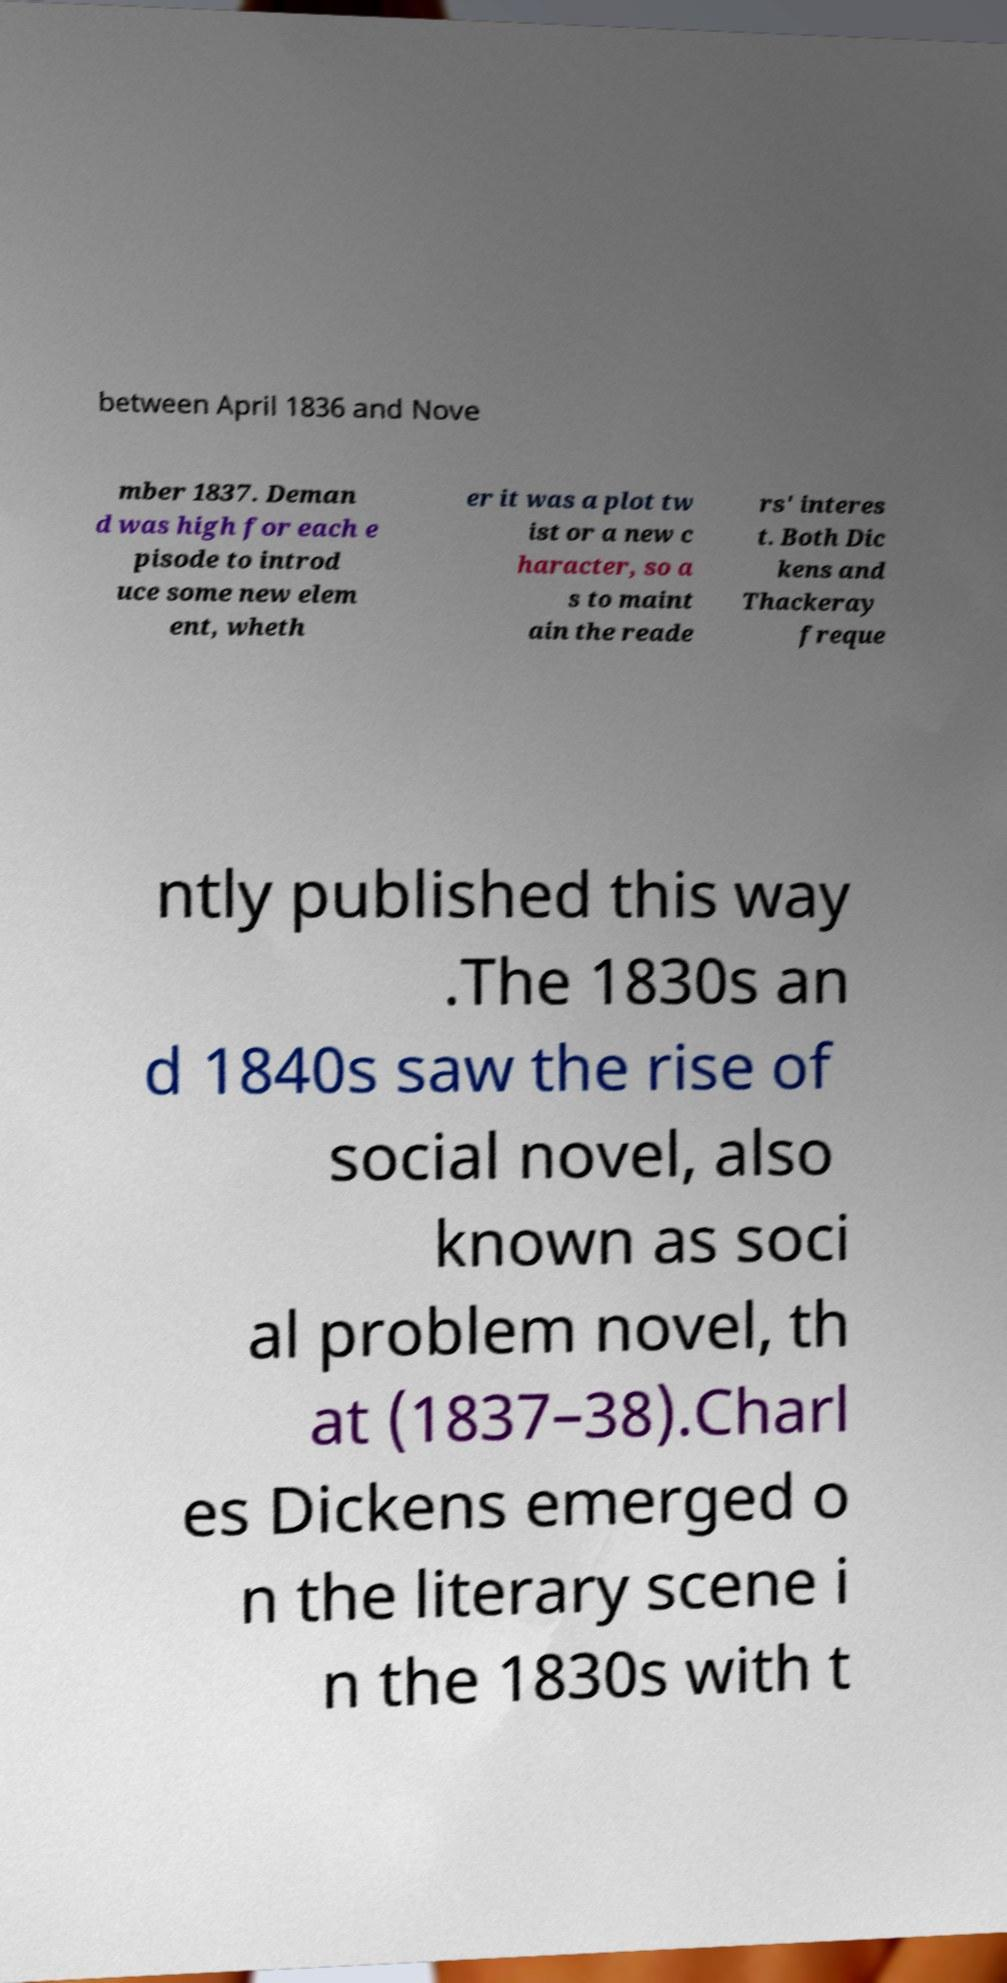For documentation purposes, I need the text within this image transcribed. Could you provide that? between April 1836 and Nove mber 1837. Deman d was high for each e pisode to introd uce some new elem ent, wheth er it was a plot tw ist or a new c haracter, so a s to maint ain the reade rs' interes t. Both Dic kens and Thackeray freque ntly published this way .The 1830s an d 1840s saw the rise of social novel, also known as soci al problem novel, th at (1837–38).Charl es Dickens emerged o n the literary scene i n the 1830s with t 